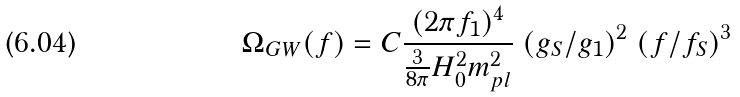<formula> <loc_0><loc_0><loc_500><loc_500>\Omega _ { G W } ( f ) = C \frac { ( 2 \pi f _ { 1 } ) ^ { 4 } } { \frac { 3 } { 8 \pi } H _ { 0 } ^ { 2 } m _ { p l } ^ { 2 } } \ ( g _ { S } / g _ { 1 } ) ^ { 2 } \ ( f / f _ { S } ) ^ { 3 }</formula> 